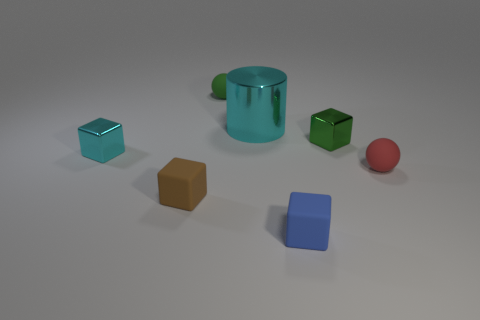What shape is the cyan thing that is on the right side of the tiny cyan shiny object?
Offer a terse response. Cylinder. Is there a sphere that is in front of the small rubber ball to the left of the green block?
Offer a very short reply. Yes. There is a metal thing that is right of the cyan block and to the left of the tiny green block; what is its color?
Your answer should be compact. Cyan. There is a small metal thing that is to the right of the ball behind the large metallic object; is there a rubber thing left of it?
Offer a very short reply. Yes. There is a green object that is the same shape as the red thing; what is its size?
Ensure brevity in your answer.  Small. Are there any purple matte things?
Your answer should be very brief. No. There is a metal cylinder; is it the same color as the small metallic block that is on the left side of the big metal cylinder?
Provide a short and direct response. Yes. There is a matte ball that is behind the small sphere in front of the tiny green thing left of the blue rubber thing; what is its size?
Give a very brief answer. Small. What number of small shiny things are the same color as the large shiny cylinder?
Offer a very short reply. 1. How many objects are either brown shiny objects or small blocks behind the tiny red rubber thing?
Give a very brief answer. 2. 